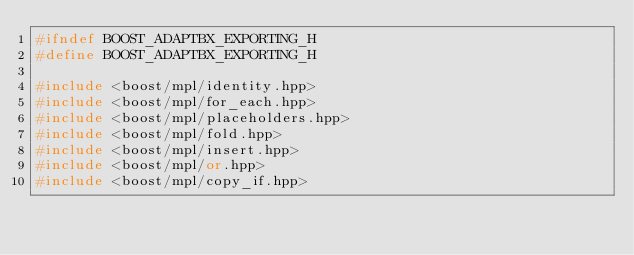<code> <loc_0><loc_0><loc_500><loc_500><_C++_>#ifndef BOOST_ADAPTBX_EXPORTING_H
#define BOOST_ADAPTBX_EXPORTING_H

#include <boost/mpl/identity.hpp>
#include <boost/mpl/for_each.hpp>
#include <boost/mpl/placeholders.hpp>
#include <boost/mpl/fold.hpp>
#include <boost/mpl/insert.hpp>
#include <boost/mpl/or.hpp>
#include <boost/mpl/copy_if.hpp>
</code> 